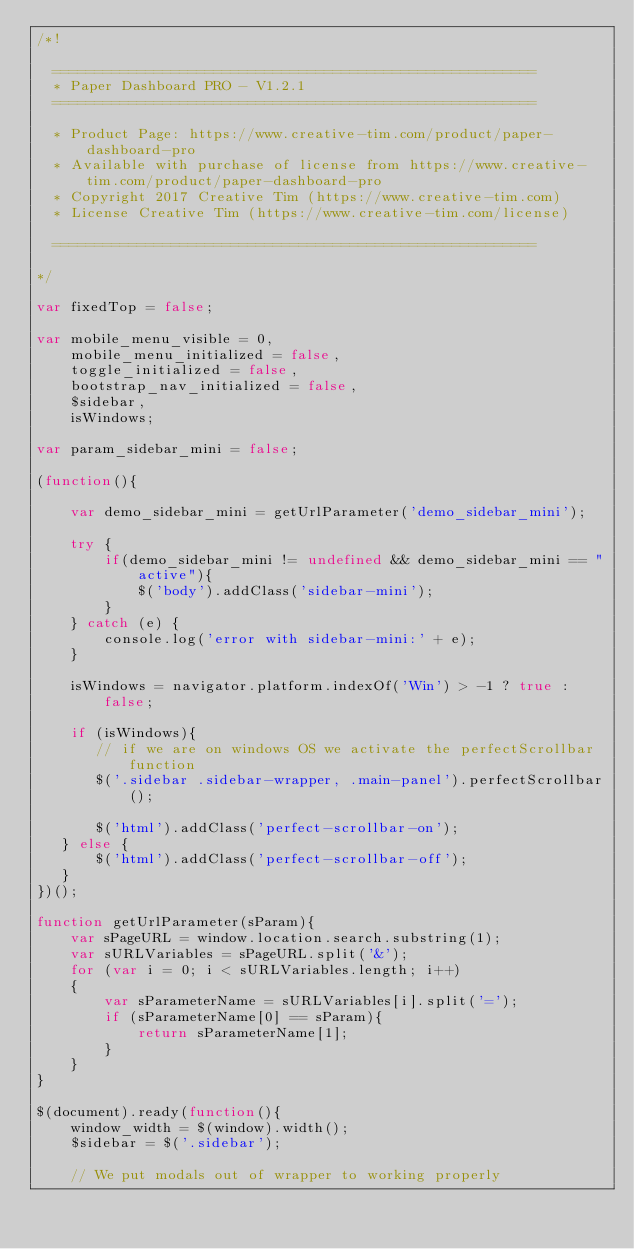Convert code to text. <code><loc_0><loc_0><loc_500><loc_500><_JavaScript_>/*!

  =========================================================
  * Paper Dashboard PRO - V1.2.1
  =========================================================

  * Product Page: https://www.creative-tim.com/product/paper-dashboard-pro
  * Available with purchase of license from https://www.creative-tim.com/product/paper-dashboard-pro
  * Copyright 2017 Creative Tim (https://www.creative-tim.com)
  * License Creative Tim (https://www.creative-tim.com/license)

  =========================================================

*/

var fixedTop = false;

var mobile_menu_visible = 0,
    mobile_menu_initialized = false,
    toggle_initialized = false,
    bootstrap_nav_initialized = false,
    $sidebar,
    isWindows;

var param_sidebar_mini = false;

(function(){

    var demo_sidebar_mini = getUrlParameter('demo_sidebar_mini');

    try {
        if(demo_sidebar_mini != undefined && demo_sidebar_mini == "active"){
            $('body').addClass('sidebar-mini');
        }
    } catch (e) {
        console.log('error with sidebar-mini:' + e);
    }

    isWindows = navigator.platform.indexOf('Win') > -1 ? true : false;

    if (isWindows){
       // if we are on windows OS we activate the perfectScrollbar function
       $('.sidebar .sidebar-wrapper, .main-panel').perfectScrollbar();

       $('html').addClass('perfect-scrollbar-on');
   } else {
       $('html').addClass('perfect-scrollbar-off');
   }
})();

function getUrlParameter(sParam){
    var sPageURL = window.location.search.substring(1);
    var sURLVariables = sPageURL.split('&');
    for (var i = 0; i < sURLVariables.length; i++)
    {
        var sParameterName = sURLVariables[i].split('=');
        if (sParameterName[0] == sParam){
            return sParameterName[1];
        }
    }
}

$(document).ready(function(){
    window_width = $(window).width();
    $sidebar = $('.sidebar');

    // We put modals out of wrapper to working properly</code> 